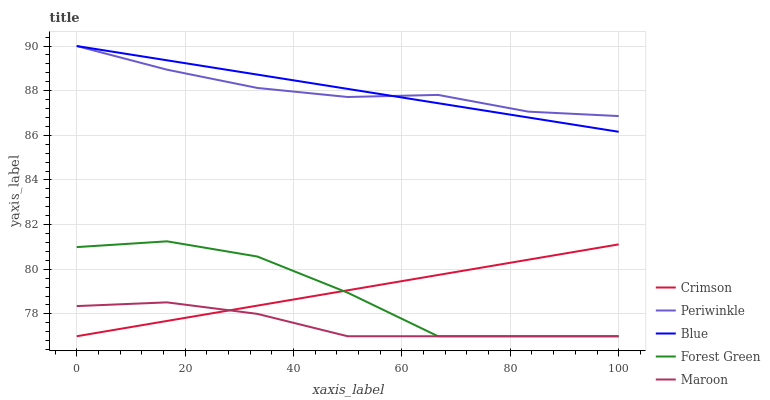Does Forest Green have the minimum area under the curve?
Answer yes or no. No. Does Forest Green have the maximum area under the curve?
Answer yes or no. No. Is Blue the smoothest?
Answer yes or no. No. Is Blue the roughest?
Answer yes or no. No. Does Blue have the lowest value?
Answer yes or no. No. Does Forest Green have the highest value?
Answer yes or no. No. Is Forest Green less than Blue?
Answer yes or no. Yes. Is Periwinkle greater than Maroon?
Answer yes or no. Yes. Does Forest Green intersect Blue?
Answer yes or no. No. 